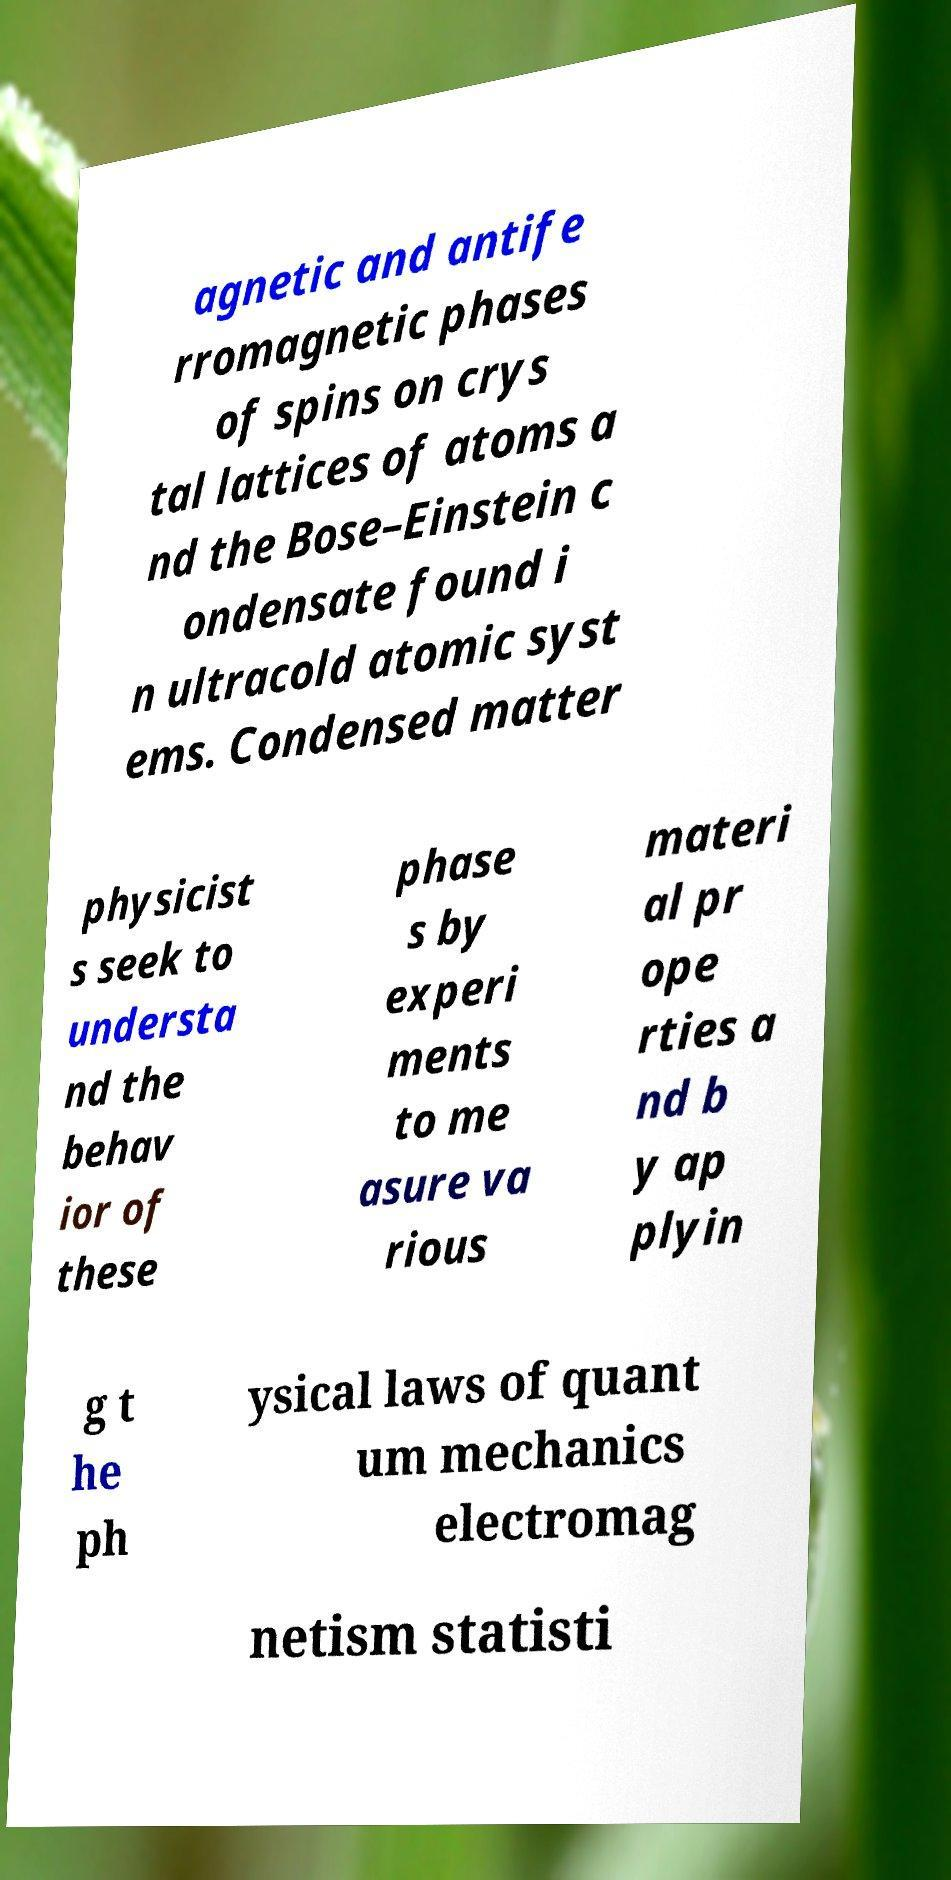Could you extract and type out the text from this image? agnetic and antife rromagnetic phases of spins on crys tal lattices of atoms a nd the Bose–Einstein c ondensate found i n ultracold atomic syst ems. Condensed matter physicist s seek to understa nd the behav ior of these phase s by experi ments to me asure va rious materi al pr ope rties a nd b y ap plyin g t he ph ysical laws of quant um mechanics electromag netism statisti 